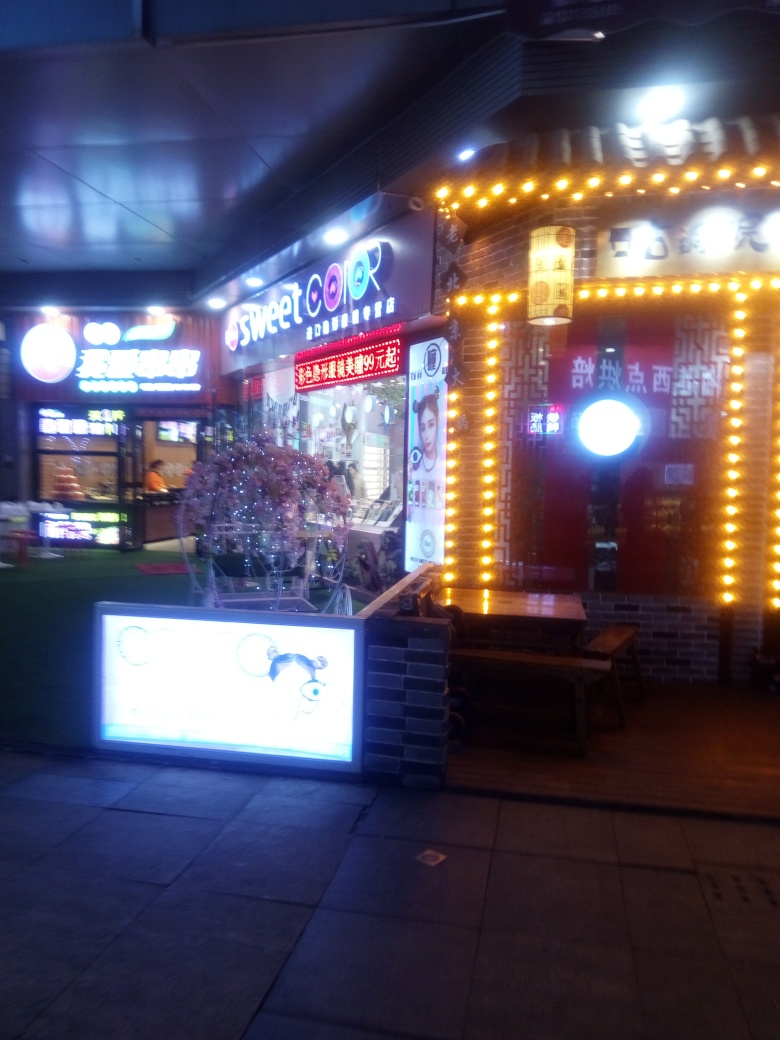Can you describe the style or vibe of the establishment shown in the image? The establishment has a flashy and vibrant look, characterized by multiple strings of bright lights that frame the storefront. It exudes a lively, attention-grabbing aura that's typical for businesses trying to stand out in a busy commercial area at night. 